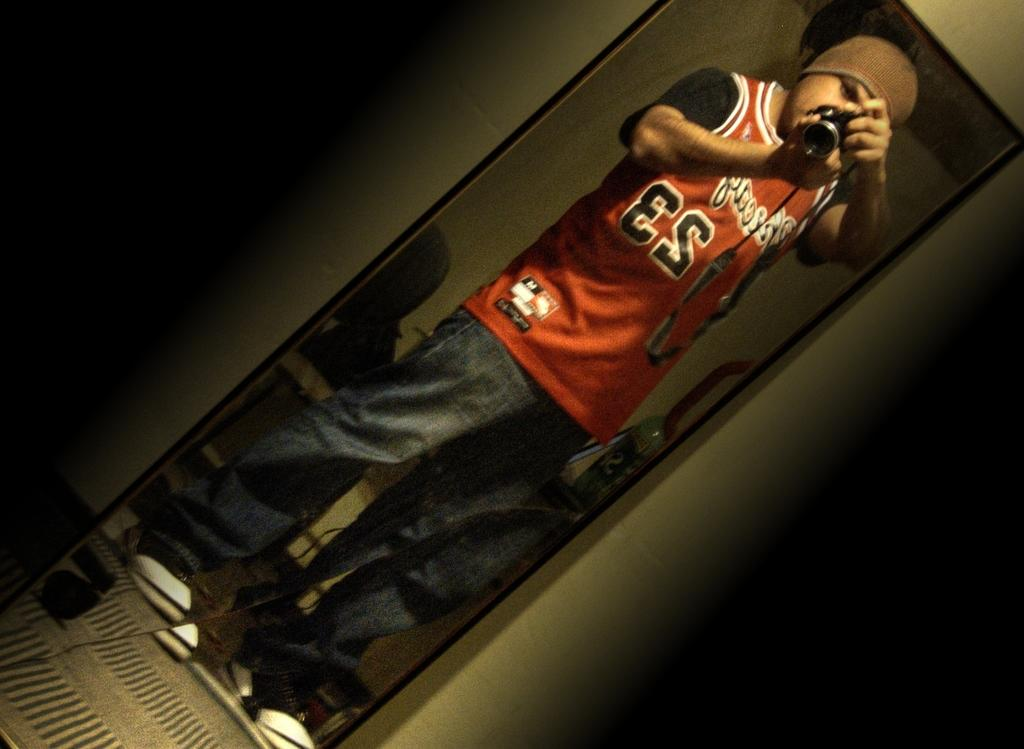<image>
Write a terse but informative summary of the picture. A man wearing an orange sports top with the number 23 on it is seen in reverse as he takes a selfie in a mirror. 